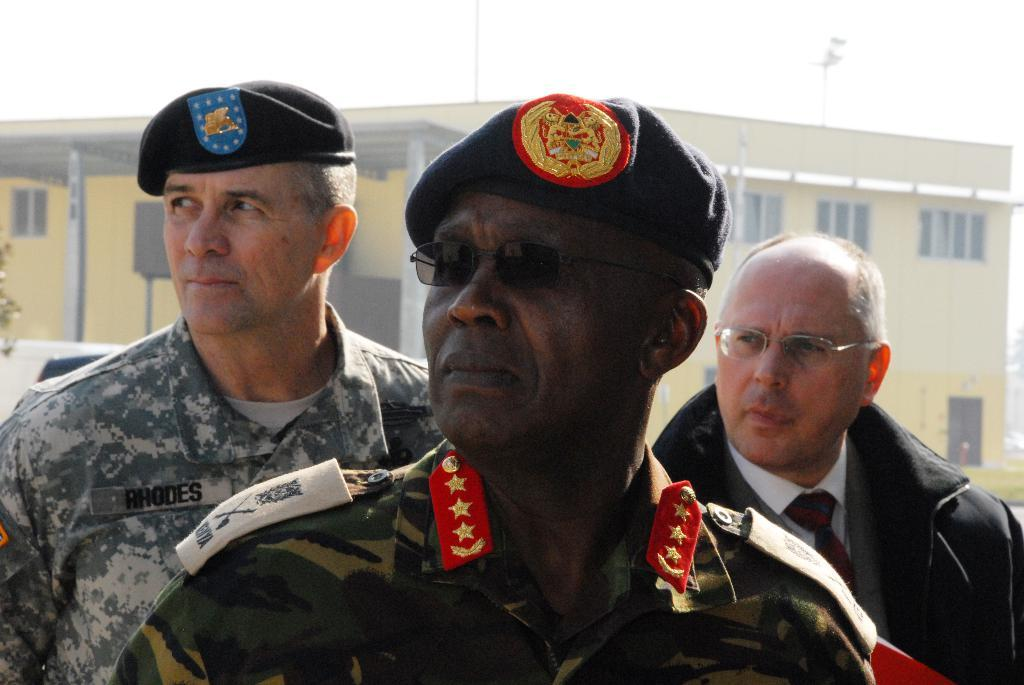How many people are present in the image? There are people in the image, but the exact number is not specified. What can be seen in the background of the image? There is a building in the background of the image. What type of yard can be seen in the image? There is no yard present in the image. How many fingers can be seen on the people in the image? The number of fingers on the people in the image cannot be determined from the provided facts. 